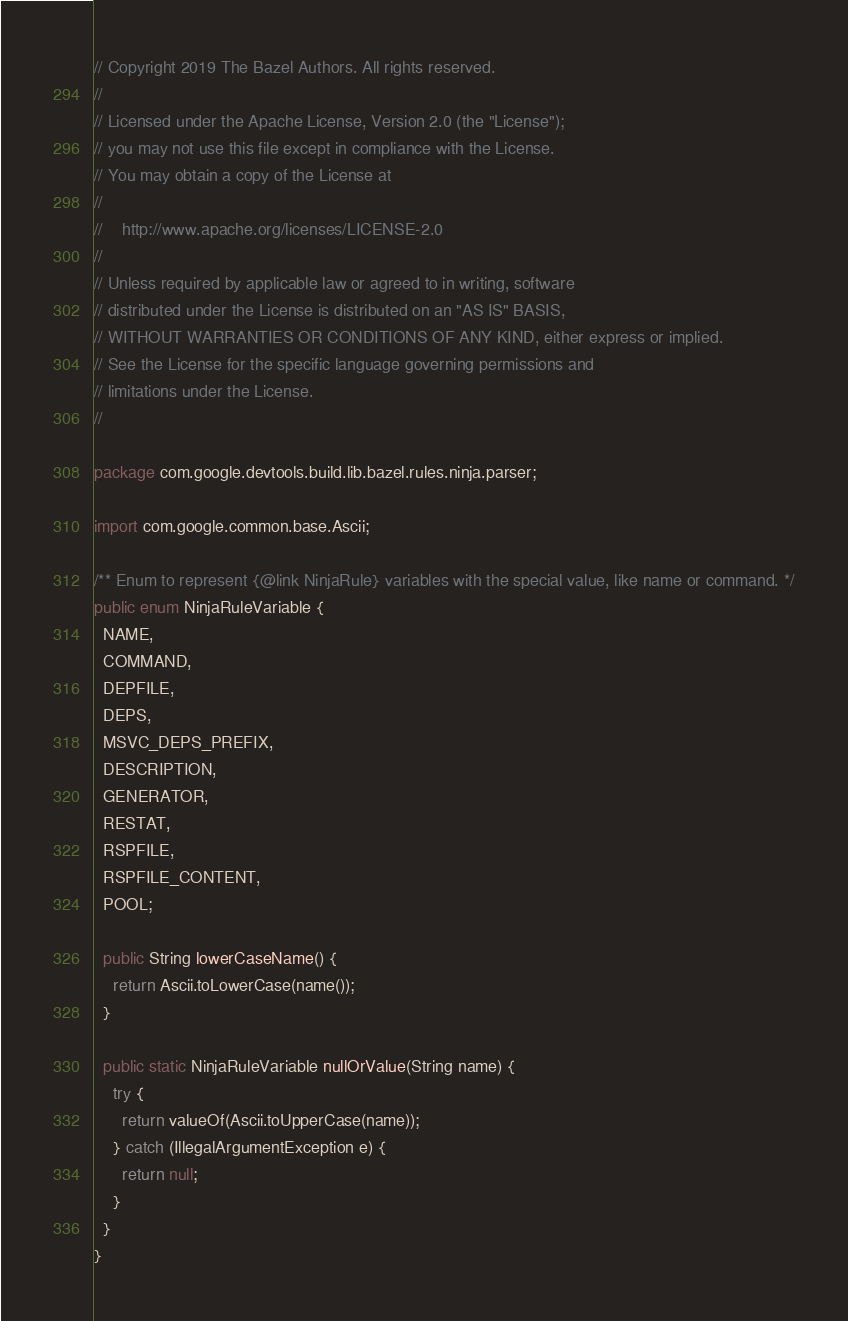<code> <loc_0><loc_0><loc_500><loc_500><_Java_>// Copyright 2019 The Bazel Authors. All rights reserved.
//
// Licensed under the Apache License, Version 2.0 (the "License");
// you may not use this file except in compliance with the License.
// You may obtain a copy of the License at
//
//    http://www.apache.org/licenses/LICENSE-2.0
//
// Unless required by applicable law or agreed to in writing, software
// distributed under the License is distributed on an "AS IS" BASIS,
// WITHOUT WARRANTIES OR CONDITIONS OF ANY KIND, either express or implied.
// See the License for the specific language governing permissions and
// limitations under the License.
//

package com.google.devtools.build.lib.bazel.rules.ninja.parser;

import com.google.common.base.Ascii;

/** Enum to represent {@link NinjaRule} variables with the special value, like name or command. */
public enum NinjaRuleVariable {
  NAME,
  COMMAND,
  DEPFILE,
  DEPS,
  MSVC_DEPS_PREFIX,
  DESCRIPTION,
  GENERATOR,
  RESTAT,
  RSPFILE,
  RSPFILE_CONTENT,
  POOL;

  public String lowerCaseName() {
    return Ascii.toLowerCase(name());
  }

  public static NinjaRuleVariable nullOrValue(String name) {
    try {
      return valueOf(Ascii.toUpperCase(name));
    } catch (IllegalArgumentException e) {
      return null;
    }
  }
}
</code> 